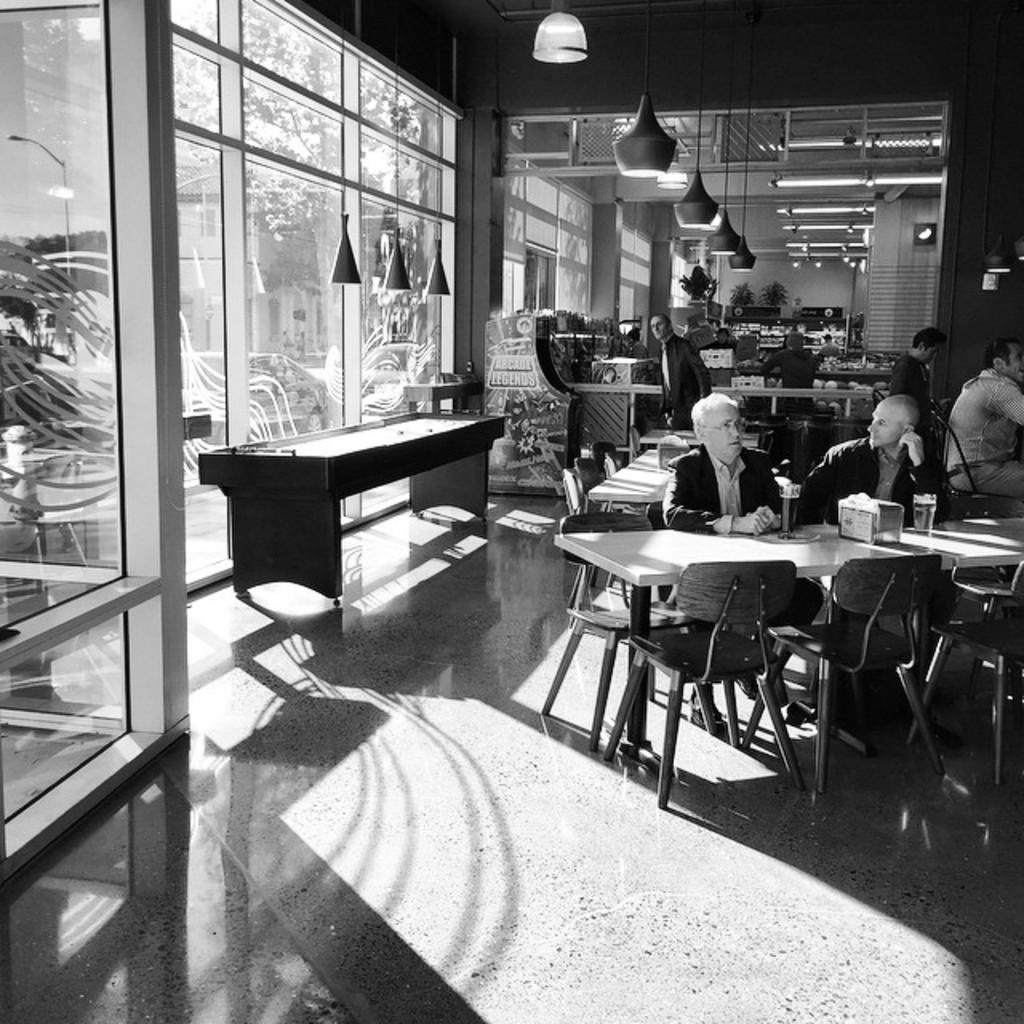How many people are in the room in the image? There is a group of persons in the room, but the exact number cannot be determined from the image. What can be seen at the top of the image? There are lights visible at the top of the image. What type of architectural feature is on the left side of the image? There are glass doors on the left side of the image. Can you see a rat playing a guitar near the glass doors in the image? No, there is no rat or guitar present in the image. 